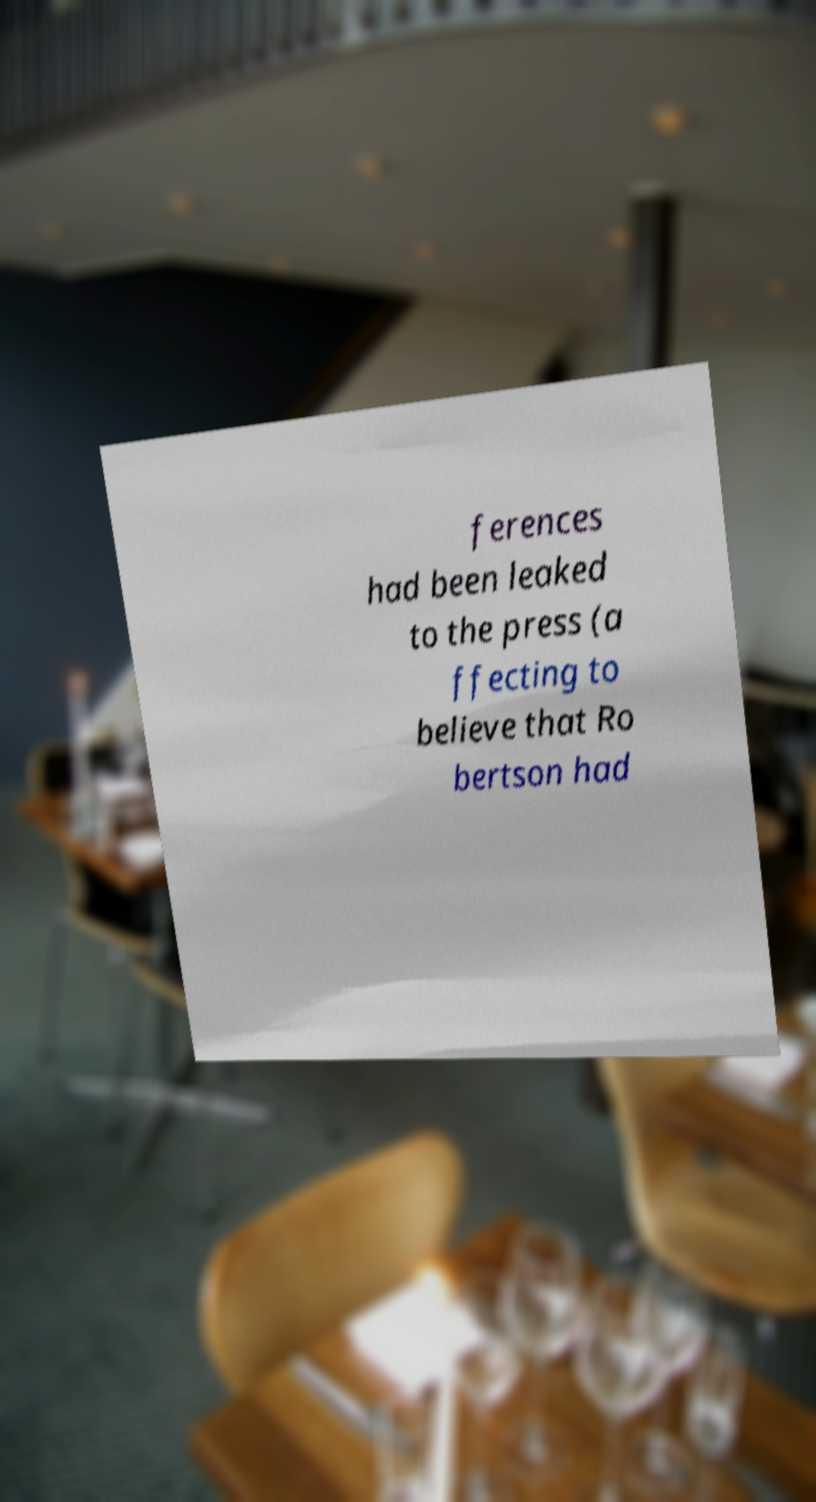Please identify and transcribe the text found in this image. ferences had been leaked to the press (a ffecting to believe that Ro bertson had 